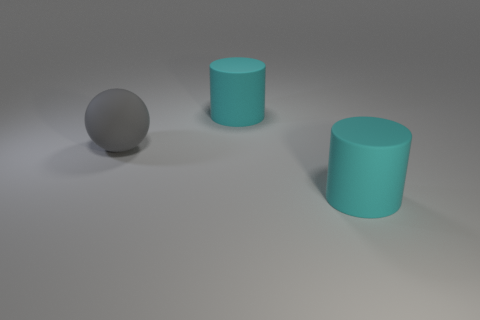Add 3 tiny blue balls. How many objects exist? 6 Subtract all balls. How many objects are left? 2 Subtract 0 green balls. How many objects are left? 3 Subtract all matte balls. Subtract all cyan rubber cylinders. How many objects are left? 0 Add 2 big gray spheres. How many big gray spheres are left? 3 Add 1 red spheres. How many red spheres exist? 1 